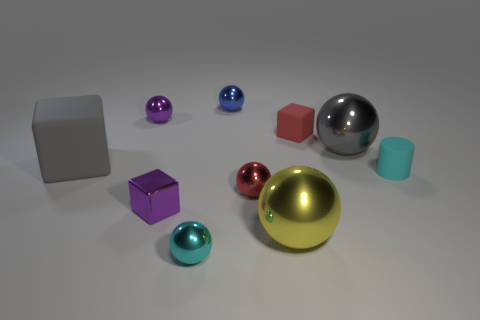What number of other things are the same material as the gray block?
Make the answer very short. 2. Do the matte cube that is behind the large gray block and the purple thing in front of the tiny red matte cube have the same size?
Your answer should be compact. Yes. What number of things are either small red matte blocks behind the shiny block or tiny metal spheres that are in front of the cyan cylinder?
Provide a succinct answer. 3. Is there anything else that is the same shape as the cyan shiny object?
Ensure brevity in your answer.  Yes. Does the large metallic sphere that is in front of the gray cube have the same color as the metallic cube to the left of the large gray ball?
Your response must be concise. No. What number of matte things are tiny brown things or gray spheres?
Offer a terse response. 0. Is there anything else that has the same size as the gray ball?
Provide a short and direct response. Yes. There is a rubber thing on the right side of the large gray object to the right of the cyan shiny thing; what is its shape?
Your answer should be compact. Cylinder. Is the small red thing that is behind the gray rubber object made of the same material as the purple thing in front of the gray metallic object?
Provide a succinct answer. No. What number of tiny rubber things are behind the big gray block left of the tiny red matte cube?
Ensure brevity in your answer.  1. 